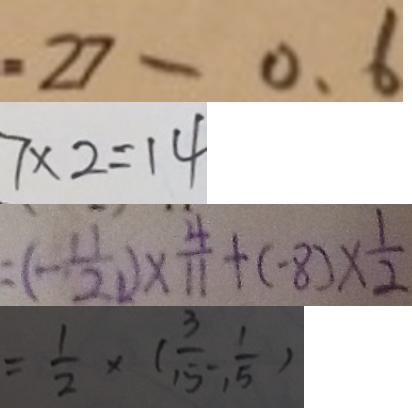<formula> <loc_0><loc_0><loc_500><loc_500>= 2 7 - 0 . 6 
 7 \times 2 = 1 4 
 = ( - \frac { 1 1 } { 2 1 } ) \times \frac { 4 } { 1 1 } + ( - 8 ) \times \frac { 1 } { 2 } 
 = \frac { 1 } { 2 } \times ( \frac { 3 } { 1 5 } - , \frac { 1 } { 1 5 } )</formula> 